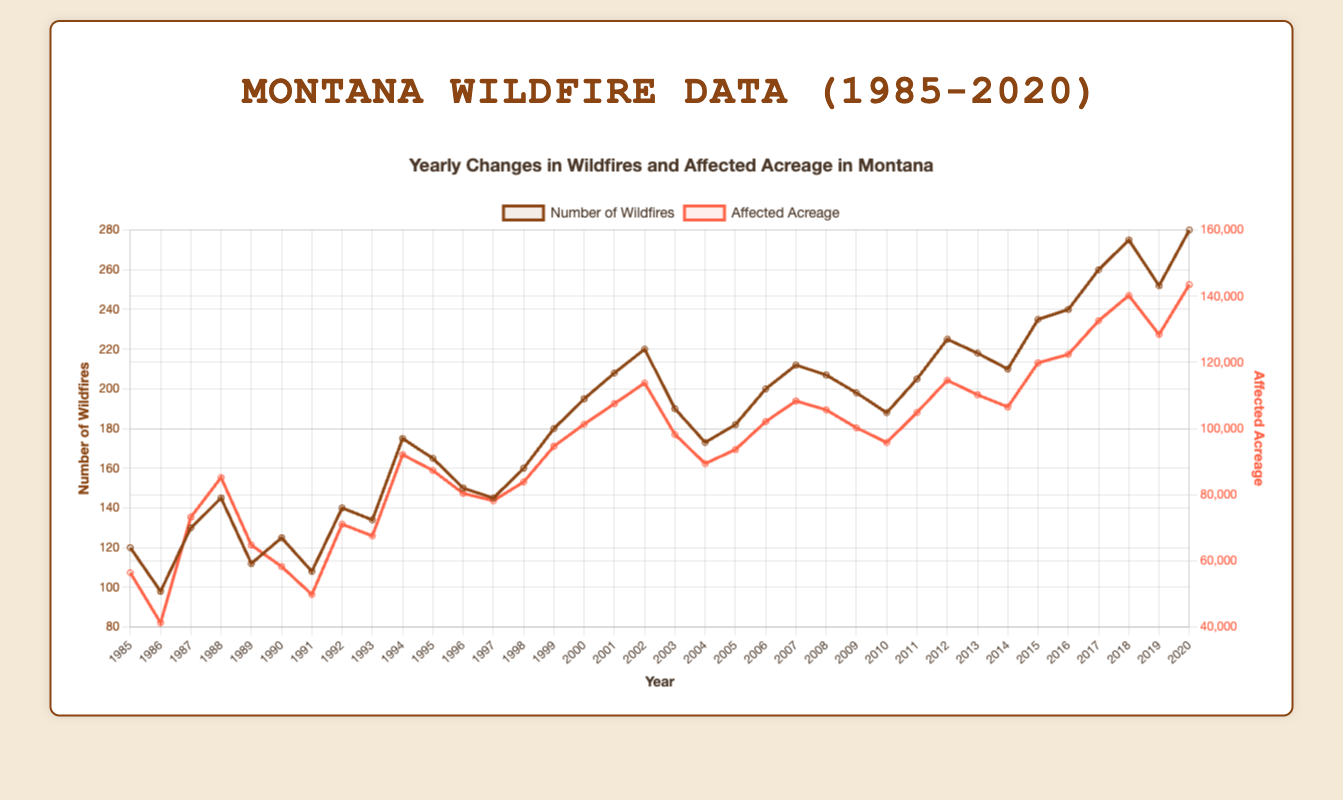What's the general trend of the number of wildfires from 1985 to 2020? By observing the line for the number of wildfires, we can see a noticeable upward trend. The number of wildfires generally increases over the years, starting from 120 in 1985 to 280 in 2020.
Answer: Upward trend How does the affected acreage in 2000 compare to the affected acreage in 2010? In 2000, the affected acreage was 101,320, while in 2010, it was 95,780. Therefore, the affected acreage in 2000 was higher than in 2010.
Answer: Higher in 2000 Which year saw the highest number of wildfires? The line representing the number of wildfires reaches its peak in 2020, indicating the highest number of wildfires occurred in that year, with 280 wildfires.
Answer: 2020 What's the average number of wildfires from 1985 to 1990? Add the number of wildfires for each year between 1985 and 1990 (120, 98, 130, 145, 112, 125), then divide by the number of years (6). The calculation is (120 + 98 + 130 + 145 + 112 + 125) / 6 = 730 / 6 = 121.7
Answer: 121.7 What's the difference in affected acreage between 2019 and 2020? In 2019, the affected acreage was 128,430 and in 2020 it was 143,520. The difference is 143,520 - 128,430 = 15,090
Answer: 15,090 In which year(s) did the number of wildfires drop compared to the previous year? By examining the line visually, the drop in the number of wildfires compared to the previous year occurred in 1986, 1989, 1991, 2003, and 2019.
Answer: 1986, 1989, 1991, 2003, 2019 What's the combined affected acreage for the years 2016, 2017, and 2018? Add the affected acreage for 2016, 2017, and 2018: (122,430 + 132,580 + 140,230). The sum is 395,240
Answer: 395,240 How many more wildfires were there in 2020 compared to 1985? In 2020, there were 280 wildfires, whereas in 1985, there were 120. The difference is 280 - 120 = 160
Answer: 160 Which year had the lowest number of wildfires and what was the number? The year with the lowest number of wildfires was 1986, with 98 wildfires. It is the lowest point on the number of wildfires line.
Answer: 1986, 98 Across the entire period, how does the trend in affected acreage compare to the trend in the number of wildfires? Both the number of wildfires and the affected acreage show an increasing trend over the years, although the lines for affected acreage have more fluctuations. The general direction for both is upward.
Answer: Increasing trend 